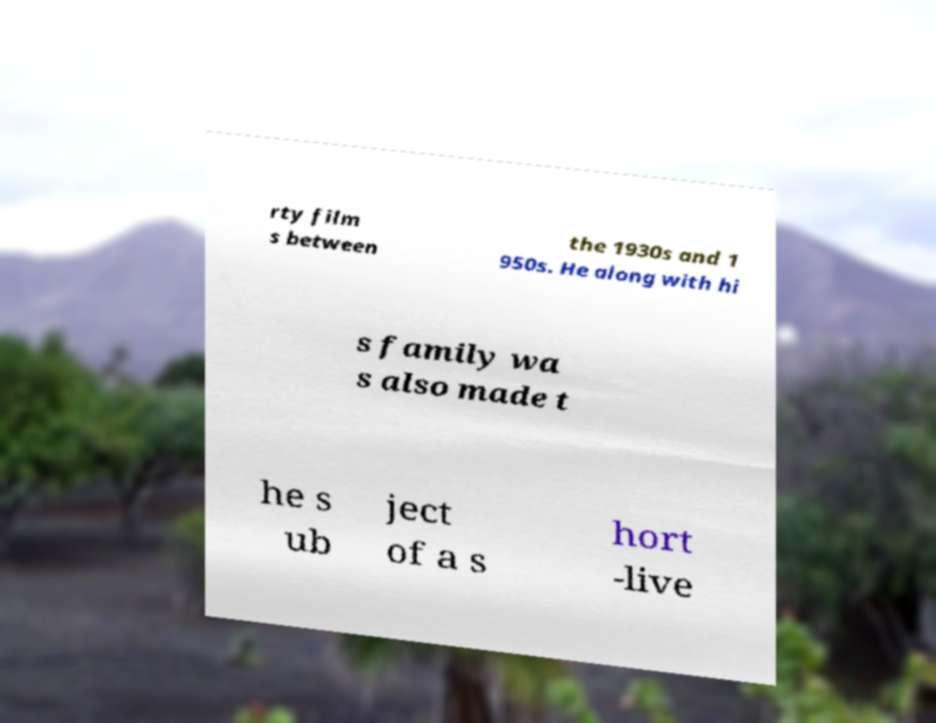For documentation purposes, I need the text within this image transcribed. Could you provide that? rty film s between the 1930s and 1 950s. He along with hi s family wa s also made t he s ub ject of a s hort -live 